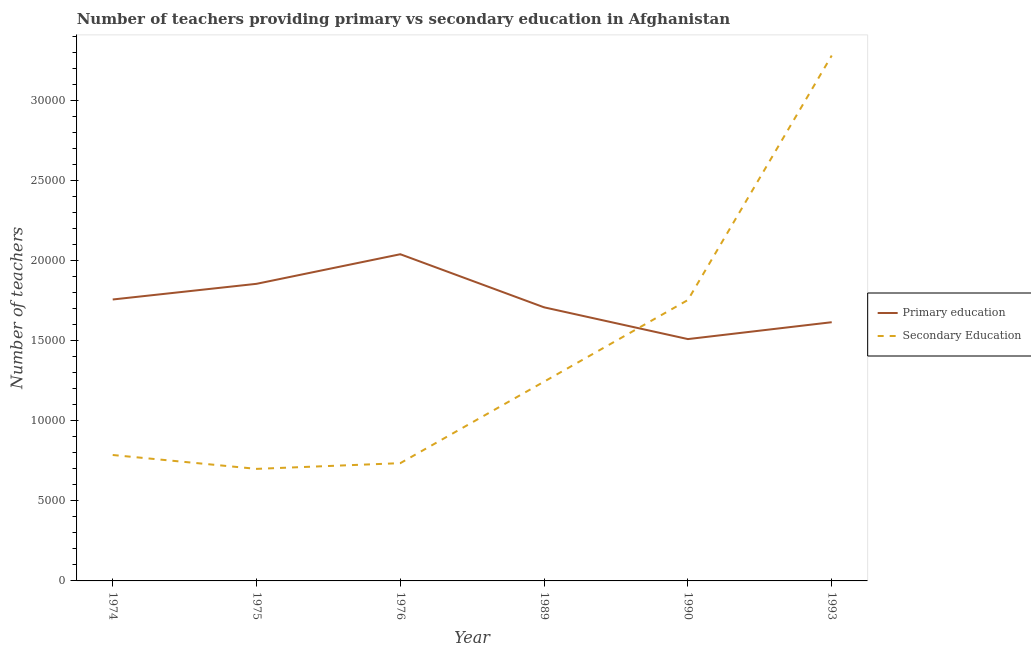How many different coloured lines are there?
Your answer should be compact. 2. Is the number of lines equal to the number of legend labels?
Offer a very short reply. Yes. What is the number of secondary teachers in 1974?
Ensure brevity in your answer.  7866. Across all years, what is the maximum number of primary teachers?
Offer a terse response. 2.04e+04. Across all years, what is the minimum number of primary teachers?
Ensure brevity in your answer.  1.51e+04. In which year was the number of primary teachers minimum?
Your answer should be very brief. 1990. What is the total number of primary teachers in the graph?
Keep it short and to the point. 1.05e+05. What is the difference between the number of primary teachers in 1976 and that in 1989?
Make the answer very short. 3317. What is the difference between the number of primary teachers in 1974 and the number of secondary teachers in 1993?
Make the answer very short. -1.52e+04. What is the average number of secondary teachers per year?
Offer a very short reply. 1.42e+04. In the year 1993, what is the difference between the number of primary teachers and number of secondary teachers?
Your answer should be compact. -1.67e+04. In how many years, is the number of secondary teachers greater than 29000?
Your response must be concise. 1. What is the ratio of the number of secondary teachers in 1974 to that in 1989?
Provide a short and direct response. 0.63. Is the difference between the number of primary teachers in 1974 and 1989 greater than the difference between the number of secondary teachers in 1974 and 1989?
Provide a short and direct response. Yes. What is the difference between the highest and the second highest number of primary teachers?
Give a very brief answer. 1848. What is the difference between the highest and the lowest number of secondary teachers?
Keep it short and to the point. 2.58e+04. In how many years, is the number of secondary teachers greater than the average number of secondary teachers taken over all years?
Your response must be concise. 2. Is the sum of the number of secondary teachers in 1975 and 1989 greater than the maximum number of primary teachers across all years?
Your response must be concise. No. How many lines are there?
Provide a succinct answer. 2. How many years are there in the graph?
Provide a succinct answer. 6. What is the difference between two consecutive major ticks on the Y-axis?
Make the answer very short. 5000. Are the values on the major ticks of Y-axis written in scientific E-notation?
Offer a very short reply. No. Does the graph contain any zero values?
Offer a terse response. No. Does the graph contain grids?
Ensure brevity in your answer.  No. How are the legend labels stacked?
Your answer should be compact. Vertical. What is the title of the graph?
Give a very brief answer. Number of teachers providing primary vs secondary education in Afghanistan. What is the label or title of the Y-axis?
Keep it short and to the point. Number of teachers. What is the Number of teachers of Primary education in 1974?
Make the answer very short. 1.76e+04. What is the Number of teachers in Secondary Education in 1974?
Provide a succinct answer. 7866. What is the Number of teachers of Primary education in 1975?
Keep it short and to the point. 1.86e+04. What is the Number of teachers in Secondary Education in 1975?
Your response must be concise. 6999. What is the Number of teachers in Primary education in 1976?
Provide a short and direct response. 2.04e+04. What is the Number of teachers in Secondary Education in 1976?
Ensure brevity in your answer.  7356. What is the Number of teachers in Primary education in 1989?
Your response must be concise. 1.71e+04. What is the Number of teachers of Secondary Education in 1989?
Give a very brief answer. 1.24e+04. What is the Number of teachers of Primary education in 1990?
Keep it short and to the point. 1.51e+04. What is the Number of teachers in Secondary Education in 1990?
Your response must be concise. 1.75e+04. What is the Number of teachers in Primary education in 1993?
Your answer should be very brief. 1.62e+04. What is the Number of teachers in Secondary Education in 1993?
Give a very brief answer. 3.28e+04. Across all years, what is the maximum Number of teachers of Primary education?
Your answer should be very brief. 2.04e+04. Across all years, what is the maximum Number of teachers in Secondary Education?
Provide a short and direct response. 3.28e+04. Across all years, what is the minimum Number of teachers in Primary education?
Your response must be concise. 1.51e+04. Across all years, what is the minimum Number of teachers in Secondary Education?
Your answer should be compact. 6999. What is the total Number of teachers of Primary education in the graph?
Your answer should be compact. 1.05e+05. What is the total Number of teachers in Secondary Education in the graph?
Your response must be concise. 8.50e+04. What is the difference between the Number of teachers of Primary education in 1974 and that in 1975?
Give a very brief answer. -979. What is the difference between the Number of teachers in Secondary Education in 1974 and that in 1975?
Your answer should be compact. 867. What is the difference between the Number of teachers in Primary education in 1974 and that in 1976?
Offer a very short reply. -2827. What is the difference between the Number of teachers in Secondary Education in 1974 and that in 1976?
Ensure brevity in your answer.  510. What is the difference between the Number of teachers in Primary education in 1974 and that in 1989?
Offer a very short reply. 490. What is the difference between the Number of teachers of Secondary Education in 1974 and that in 1989?
Your answer should be very brief. -4582. What is the difference between the Number of teachers in Primary education in 1974 and that in 1990?
Provide a succinct answer. 2473. What is the difference between the Number of teachers of Secondary Education in 1974 and that in 1990?
Your answer should be compact. -9682. What is the difference between the Number of teachers in Primary education in 1974 and that in 1993?
Provide a short and direct response. 1419. What is the difference between the Number of teachers in Secondary Education in 1974 and that in 1993?
Give a very brief answer. -2.50e+04. What is the difference between the Number of teachers in Primary education in 1975 and that in 1976?
Your answer should be very brief. -1848. What is the difference between the Number of teachers of Secondary Education in 1975 and that in 1976?
Your response must be concise. -357. What is the difference between the Number of teachers in Primary education in 1975 and that in 1989?
Offer a terse response. 1469. What is the difference between the Number of teachers of Secondary Education in 1975 and that in 1989?
Give a very brief answer. -5449. What is the difference between the Number of teachers in Primary education in 1975 and that in 1990?
Keep it short and to the point. 3452. What is the difference between the Number of teachers of Secondary Education in 1975 and that in 1990?
Offer a terse response. -1.05e+04. What is the difference between the Number of teachers of Primary education in 1975 and that in 1993?
Provide a short and direct response. 2398. What is the difference between the Number of teachers in Secondary Education in 1975 and that in 1993?
Keep it short and to the point. -2.58e+04. What is the difference between the Number of teachers in Primary education in 1976 and that in 1989?
Keep it short and to the point. 3317. What is the difference between the Number of teachers in Secondary Education in 1976 and that in 1989?
Keep it short and to the point. -5092. What is the difference between the Number of teachers of Primary education in 1976 and that in 1990?
Your answer should be compact. 5300. What is the difference between the Number of teachers in Secondary Education in 1976 and that in 1990?
Provide a short and direct response. -1.02e+04. What is the difference between the Number of teachers of Primary education in 1976 and that in 1993?
Provide a short and direct response. 4246. What is the difference between the Number of teachers in Secondary Education in 1976 and that in 1993?
Give a very brief answer. -2.55e+04. What is the difference between the Number of teachers in Primary education in 1989 and that in 1990?
Offer a very short reply. 1983. What is the difference between the Number of teachers of Secondary Education in 1989 and that in 1990?
Provide a succinct answer. -5100. What is the difference between the Number of teachers of Primary education in 1989 and that in 1993?
Keep it short and to the point. 929. What is the difference between the Number of teachers in Secondary Education in 1989 and that in 1993?
Provide a succinct answer. -2.04e+04. What is the difference between the Number of teachers of Primary education in 1990 and that in 1993?
Offer a very short reply. -1054. What is the difference between the Number of teachers of Secondary Education in 1990 and that in 1993?
Your answer should be very brief. -1.53e+04. What is the difference between the Number of teachers of Primary education in 1974 and the Number of teachers of Secondary Education in 1975?
Provide a short and direct response. 1.06e+04. What is the difference between the Number of teachers in Primary education in 1974 and the Number of teachers in Secondary Education in 1976?
Ensure brevity in your answer.  1.02e+04. What is the difference between the Number of teachers in Primary education in 1974 and the Number of teachers in Secondary Education in 1989?
Give a very brief answer. 5131. What is the difference between the Number of teachers of Primary education in 1974 and the Number of teachers of Secondary Education in 1990?
Keep it short and to the point. 31. What is the difference between the Number of teachers of Primary education in 1974 and the Number of teachers of Secondary Education in 1993?
Offer a very short reply. -1.52e+04. What is the difference between the Number of teachers in Primary education in 1975 and the Number of teachers in Secondary Education in 1976?
Offer a very short reply. 1.12e+04. What is the difference between the Number of teachers in Primary education in 1975 and the Number of teachers in Secondary Education in 1989?
Your answer should be compact. 6110. What is the difference between the Number of teachers in Primary education in 1975 and the Number of teachers in Secondary Education in 1990?
Give a very brief answer. 1010. What is the difference between the Number of teachers in Primary education in 1975 and the Number of teachers in Secondary Education in 1993?
Your answer should be compact. -1.43e+04. What is the difference between the Number of teachers of Primary education in 1976 and the Number of teachers of Secondary Education in 1989?
Make the answer very short. 7958. What is the difference between the Number of teachers in Primary education in 1976 and the Number of teachers in Secondary Education in 1990?
Make the answer very short. 2858. What is the difference between the Number of teachers in Primary education in 1976 and the Number of teachers in Secondary Education in 1993?
Provide a succinct answer. -1.24e+04. What is the difference between the Number of teachers of Primary education in 1989 and the Number of teachers of Secondary Education in 1990?
Offer a very short reply. -459. What is the difference between the Number of teachers in Primary education in 1989 and the Number of teachers in Secondary Education in 1993?
Make the answer very short. -1.57e+04. What is the difference between the Number of teachers in Primary education in 1990 and the Number of teachers in Secondary Education in 1993?
Provide a short and direct response. -1.77e+04. What is the average Number of teachers of Primary education per year?
Provide a short and direct response. 1.75e+04. What is the average Number of teachers of Secondary Education per year?
Provide a short and direct response. 1.42e+04. In the year 1974, what is the difference between the Number of teachers of Primary education and Number of teachers of Secondary Education?
Your answer should be compact. 9713. In the year 1975, what is the difference between the Number of teachers in Primary education and Number of teachers in Secondary Education?
Ensure brevity in your answer.  1.16e+04. In the year 1976, what is the difference between the Number of teachers in Primary education and Number of teachers in Secondary Education?
Your response must be concise. 1.30e+04. In the year 1989, what is the difference between the Number of teachers in Primary education and Number of teachers in Secondary Education?
Keep it short and to the point. 4641. In the year 1990, what is the difference between the Number of teachers of Primary education and Number of teachers of Secondary Education?
Offer a terse response. -2442. In the year 1993, what is the difference between the Number of teachers in Primary education and Number of teachers in Secondary Education?
Your answer should be very brief. -1.67e+04. What is the ratio of the Number of teachers in Primary education in 1974 to that in 1975?
Ensure brevity in your answer.  0.95. What is the ratio of the Number of teachers of Secondary Education in 1974 to that in 1975?
Keep it short and to the point. 1.12. What is the ratio of the Number of teachers of Primary education in 1974 to that in 1976?
Ensure brevity in your answer.  0.86. What is the ratio of the Number of teachers of Secondary Education in 1974 to that in 1976?
Give a very brief answer. 1.07. What is the ratio of the Number of teachers of Primary education in 1974 to that in 1989?
Keep it short and to the point. 1.03. What is the ratio of the Number of teachers of Secondary Education in 1974 to that in 1989?
Your response must be concise. 0.63. What is the ratio of the Number of teachers of Primary education in 1974 to that in 1990?
Offer a very short reply. 1.16. What is the ratio of the Number of teachers of Secondary Education in 1974 to that in 1990?
Your response must be concise. 0.45. What is the ratio of the Number of teachers in Primary education in 1974 to that in 1993?
Ensure brevity in your answer.  1.09. What is the ratio of the Number of teachers in Secondary Education in 1974 to that in 1993?
Your answer should be very brief. 0.24. What is the ratio of the Number of teachers of Primary education in 1975 to that in 1976?
Your answer should be very brief. 0.91. What is the ratio of the Number of teachers in Secondary Education in 1975 to that in 1976?
Your answer should be compact. 0.95. What is the ratio of the Number of teachers of Primary education in 1975 to that in 1989?
Provide a succinct answer. 1.09. What is the ratio of the Number of teachers in Secondary Education in 1975 to that in 1989?
Make the answer very short. 0.56. What is the ratio of the Number of teachers in Primary education in 1975 to that in 1990?
Your response must be concise. 1.23. What is the ratio of the Number of teachers in Secondary Education in 1975 to that in 1990?
Keep it short and to the point. 0.4. What is the ratio of the Number of teachers in Primary education in 1975 to that in 1993?
Your answer should be very brief. 1.15. What is the ratio of the Number of teachers in Secondary Education in 1975 to that in 1993?
Offer a very short reply. 0.21. What is the ratio of the Number of teachers in Primary education in 1976 to that in 1989?
Provide a succinct answer. 1.19. What is the ratio of the Number of teachers in Secondary Education in 1976 to that in 1989?
Give a very brief answer. 0.59. What is the ratio of the Number of teachers of Primary education in 1976 to that in 1990?
Your answer should be very brief. 1.35. What is the ratio of the Number of teachers of Secondary Education in 1976 to that in 1990?
Your response must be concise. 0.42. What is the ratio of the Number of teachers of Primary education in 1976 to that in 1993?
Offer a very short reply. 1.26. What is the ratio of the Number of teachers of Secondary Education in 1976 to that in 1993?
Offer a very short reply. 0.22. What is the ratio of the Number of teachers in Primary education in 1989 to that in 1990?
Offer a very short reply. 1.13. What is the ratio of the Number of teachers in Secondary Education in 1989 to that in 1990?
Make the answer very short. 0.71. What is the ratio of the Number of teachers in Primary education in 1989 to that in 1993?
Your response must be concise. 1.06. What is the ratio of the Number of teachers in Secondary Education in 1989 to that in 1993?
Provide a succinct answer. 0.38. What is the ratio of the Number of teachers in Primary education in 1990 to that in 1993?
Provide a short and direct response. 0.93. What is the ratio of the Number of teachers in Secondary Education in 1990 to that in 1993?
Ensure brevity in your answer.  0.53. What is the difference between the highest and the second highest Number of teachers in Primary education?
Make the answer very short. 1848. What is the difference between the highest and the second highest Number of teachers of Secondary Education?
Make the answer very short. 1.53e+04. What is the difference between the highest and the lowest Number of teachers in Primary education?
Your answer should be very brief. 5300. What is the difference between the highest and the lowest Number of teachers of Secondary Education?
Offer a terse response. 2.58e+04. 